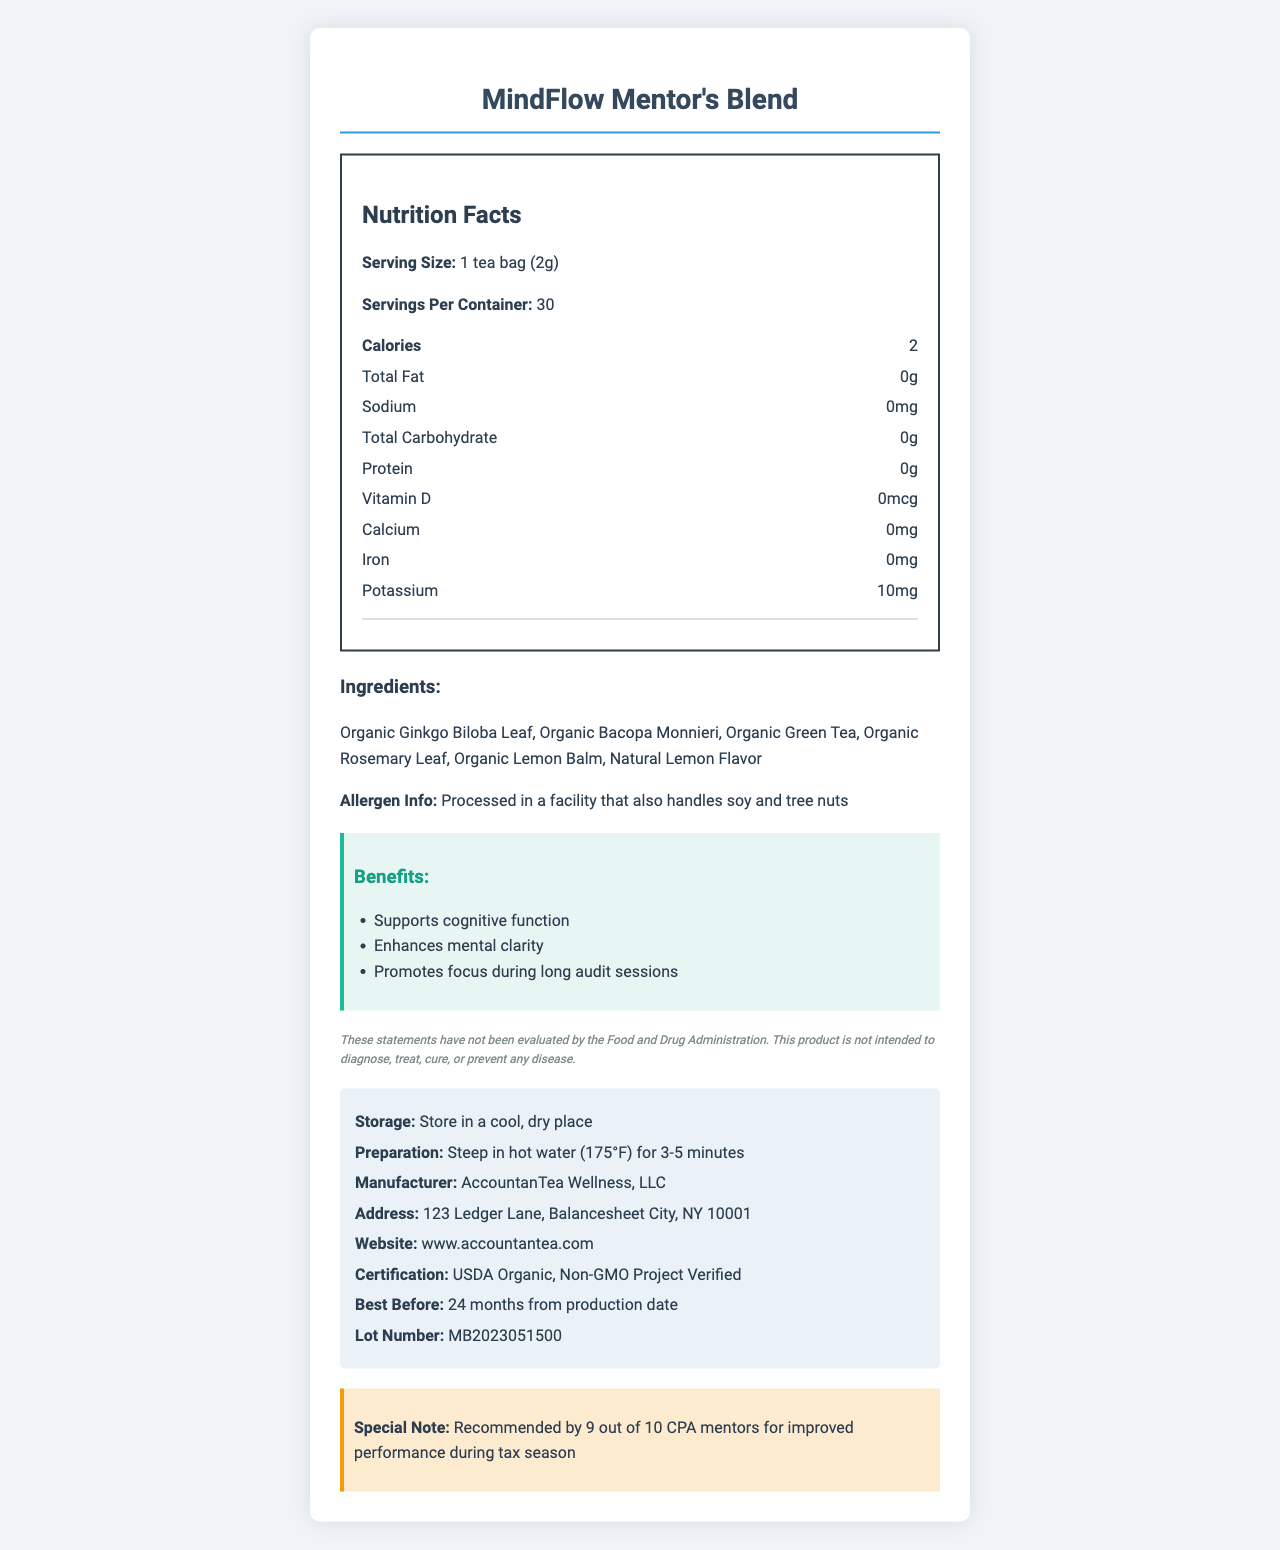what is the serving size of the MindFlow Mentor's Blend? The serving size is explicitly listed as "1 tea bag (2g)" under the Nutrition Facts section.
Answer: 1 tea bag (2g) how many servings are there in a container? The document states "Servings Per Container: 30" in the Nutrition Facts section.
Answer: 30 how many calories are in one serving? Under the Nutrition Facts, it lists "Calories: 2".
Answer: 2 what is the amount of potassium in one serving? The Nutrition Facts section indicates "Potassium: 10mg".
Answer: 10mg what ingredients are included in MindFlow Mentor's Blend? The ingredients are listed under the "Ingredients" section of the document.
Answer: Organic Ginkgo Biloba Leaf, Organic Bacopa Monnieri, Organic Green Tea, Organic Rosemary Leaf, Organic Lemon Balm, Natural Lemon Flavor what certifications does the product have? A. Non-GMO Project Verified B. USDA Organic C. None D. Both A and B The additional info section lists the certifications as "USDA Organic, Non-GMO Project Verified."
Answer: D. Both A and B where is the product manufactured? A. New York, NY B. Balancesheet City, NY C. Brooklyn, NY D. Albany, NY The address given in the additional info section is "123 Ledger Lane, Balancesheet City, NY 10001".
Answer: B. Balancesheet City, NY is this product allergen-free? The ingredients section specifies that it is "Processed in a facility that also handles soy and tree nuts."
Answer: No does the tea blend contain any protein? The Nutrition Facts section shows "Protein: 0g".
Answer: No summarize the main idea of the document. The document comprehensively describes the content and benefits of MindFlow Mentor's Blend, provides nutrition details, ingredients, and additional information regarding the product's handling and certifications.
Answer: The document provides the Nutrition Facts label for MindFlow Mentor's Blend, a brain-boosting herbal tea. It includes the serving size, servings per container, calorie count, and details of macronutrients and micronutrients. It lists the organic ingredients, allergen information, benefits, storage, and preparation instructions, along with manufacturer details and certifications. how long does the product last before it expires? The additional info section specifies "Best Before: 24 months from production date."
Answer: 24 months from production date can this tea blend diagnose, treat, or cure diseases? The disclaimer clearly states, "This product is not intended to diagnose, treat, cure, or prevent any disease."
Answer: No when should the tea be stored? The additional info section specifies, "Store in a cool, dry place."
Answer: In a cool, dry place does the tea contain any amount of vitamin D? The Nutrition Facts section shows "Vitamin D: 0mcg."
Answer: No how should the tea be prepared for optimal flavor? The additional info section provides proper preparation instructions as "Steep in hot water (175°F) for 3-5 minutes."
Answer: Steep in hot water (175°F) for 3-5 minutes how many CPA mentors recommend this product during tax season? The "special note" at the end of the document mentions, "Recommended by 9 out of 10 CPA mentors for improved performance during tax season."
Answer: 9 out of 10 what is the price of the MindFlow Mentor's Blend? The document does not provide any pricing information.
Answer: Cannot be determined 